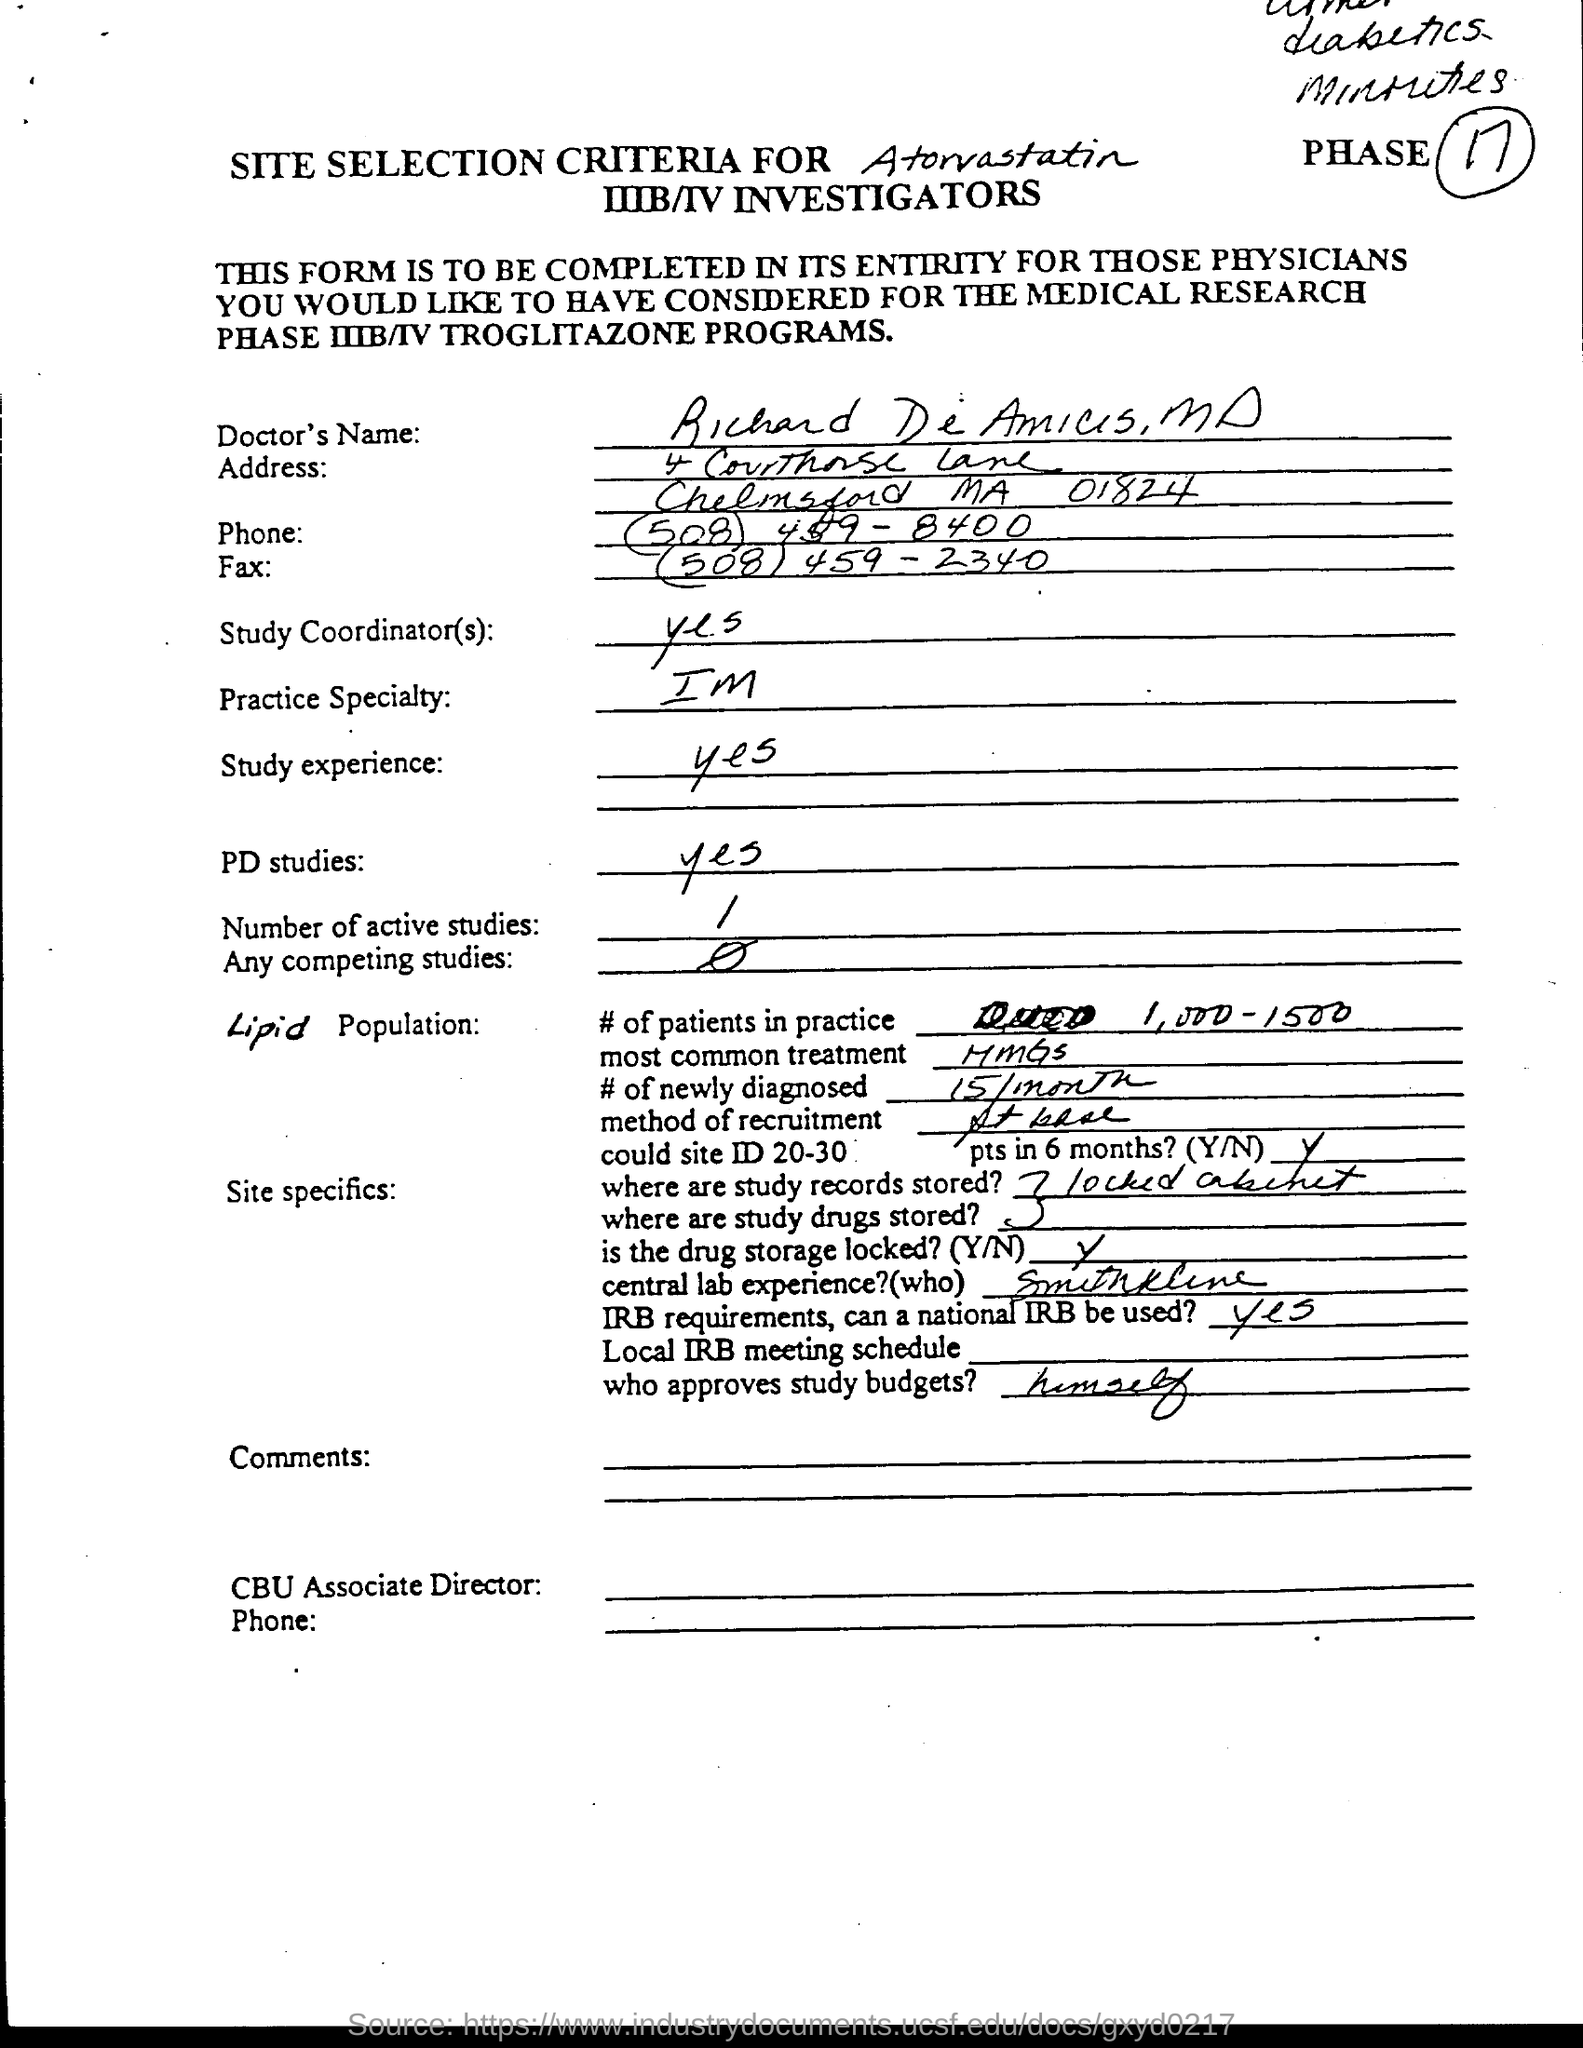What is the phase number?
Your response must be concise. 17. What is the practice speciality?
Your answer should be very brief. IM. What is the number of active studies?
Ensure brevity in your answer.  1. Who approves study budget?
Give a very brief answer. Himself. Where are study records and study drugs stored?
Give a very brief answer. Locked cabinet. What is the number of newly diagonised?
Keep it short and to the point. 15/month. 